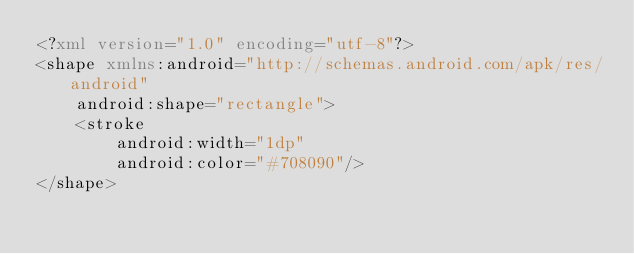<code> <loc_0><loc_0><loc_500><loc_500><_XML_><?xml version="1.0" encoding="utf-8"?>
<shape xmlns:android="http://schemas.android.com/apk/res/android"
    android:shape="rectangle">
    <stroke
        android:width="1dp"
        android:color="#708090"/>
</shape></code> 